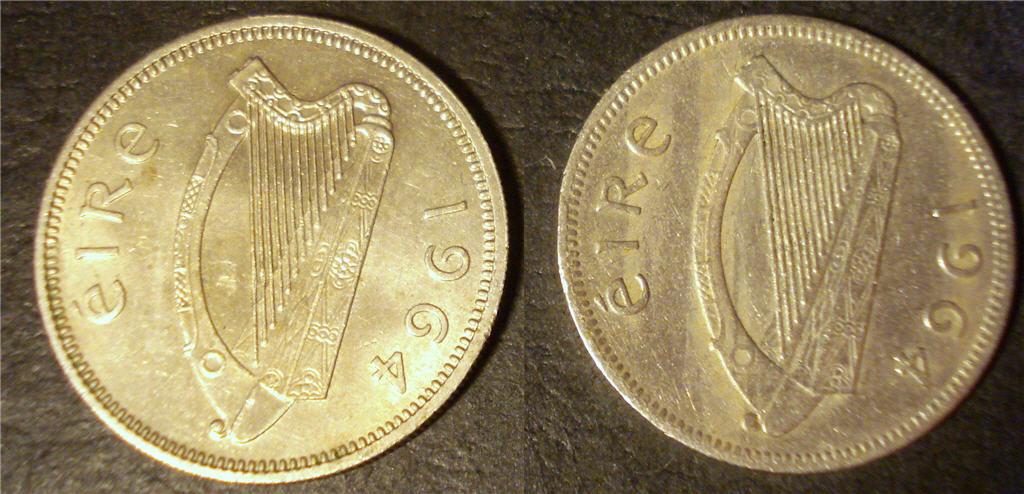What year are the coins?
Give a very brief answer. 1964. What is the word on the coins?
Offer a very short reply. Eire. 